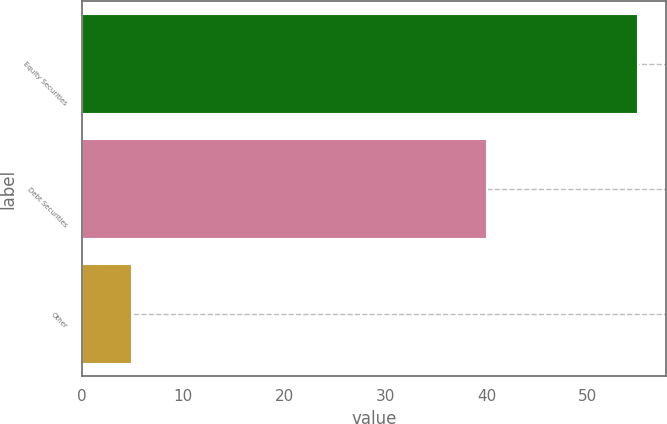Convert chart to OTSL. <chart><loc_0><loc_0><loc_500><loc_500><bar_chart><fcel>Equity Securities<fcel>Debt Securities<fcel>Other<nl><fcel>55<fcel>40<fcel>5<nl></chart> 